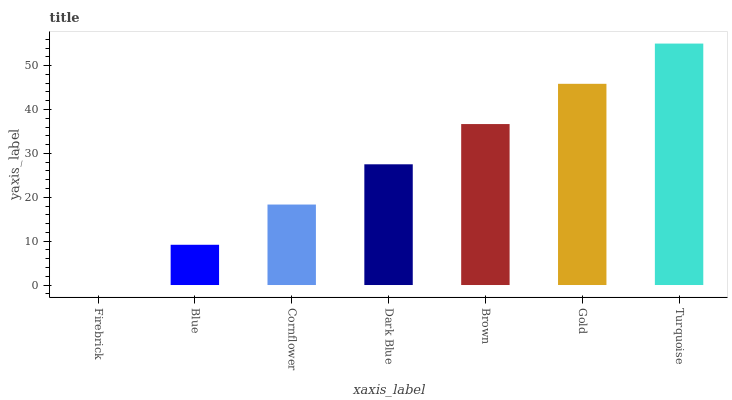Is Firebrick the minimum?
Answer yes or no. Yes. Is Turquoise the maximum?
Answer yes or no. Yes. Is Blue the minimum?
Answer yes or no. No. Is Blue the maximum?
Answer yes or no. No. Is Blue greater than Firebrick?
Answer yes or no. Yes. Is Firebrick less than Blue?
Answer yes or no. Yes. Is Firebrick greater than Blue?
Answer yes or no. No. Is Blue less than Firebrick?
Answer yes or no. No. Is Dark Blue the high median?
Answer yes or no. Yes. Is Dark Blue the low median?
Answer yes or no. Yes. Is Gold the high median?
Answer yes or no. No. Is Turquoise the low median?
Answer yes or no. No. 